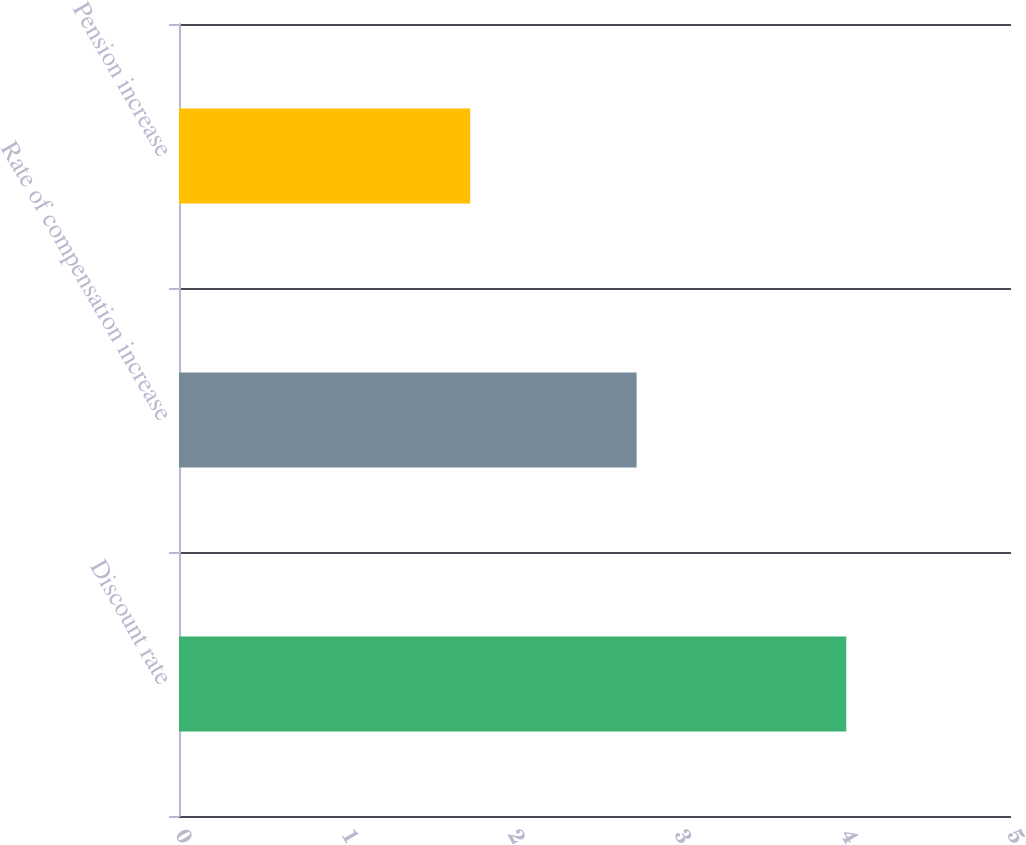Convert chart to OTSL. <chart><loc_0><loc_0><loc_500><loc_500><bar_chart><fcel>Discount rate<fcel>Rate of compensation increase<fcel>Pension increase<nl><fcel>4.01<fcel>2.75<fcel>1.75<nl></chart> 